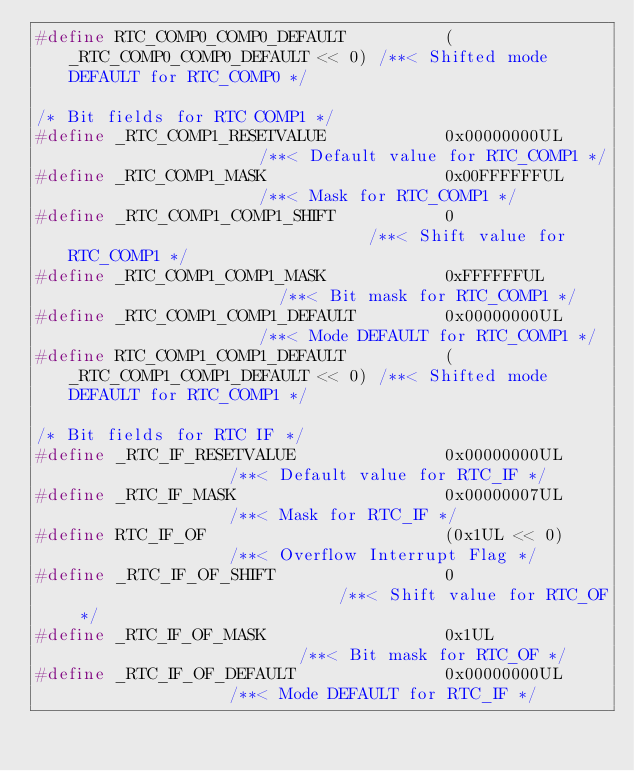<code> <loc_0><loc_0><loc_500><loc_500><_C_>#define RTC_COMP0_COMP0_DEFAULT          (_RTC_COMP0_COMP0_DEFAULT << 0) /**< Shifted mode DEFAULT for RTC_COMP0 */

/* Bit fields for RTC COMP1 */
#define _RTC_COMP1_RESETVALUE            0x00000000UL                    /**< Default value for RTC_COMP1 */
#define _RTC_COMP1_MASK                  0x00FFFFFFUL                    /**< Mask for RTC_COMP1 */
#define _RTC_COMP1_COMP1_SHIFT           0                               /**< Shift value for RTC_COMP1 */
#define _RTC_COMP1_COMP1_MASK            0xFFFFFFUL                      /**< Bit mask for RTC_COMP1 */
#define _RTC_COMP1_COMP1_DEFAULT         0x00000000UL                    /**< Mode DEFAULT for RTC_COMP1 */
#define RTC_COMP1_COMP1_DEFAULT          (_RTC_COMP1_COMP1_DEFAULT << 0) /**< Shifted mode DEFAULT for RTC_COMP1 */

/* Bit fields for RTC IF */
#define _RTC_IF_RESETVALUE               0x00000000UL                 /**< Default value for RTC_IF */
#define _RTC_IF_MASK                     0x00000007UL                 /**< Mask for RTC_IF */
#define RTC_IF_OF                        (0x1UL << 0)                 /**< Overflow Interrupt Flag */
#define _RTC_IF_OF_SHIFT                 0                            /**< Shift value for RTC_OF */
#define _RTC_IF_OF_MASK                  0x1UL                        /**< Bit mask for RTC_OF */
#define _RTC_IF_OF_DEFAULT               0x00000000UL                 /**< Mode DEFAULT for RTC_IF */</code> 